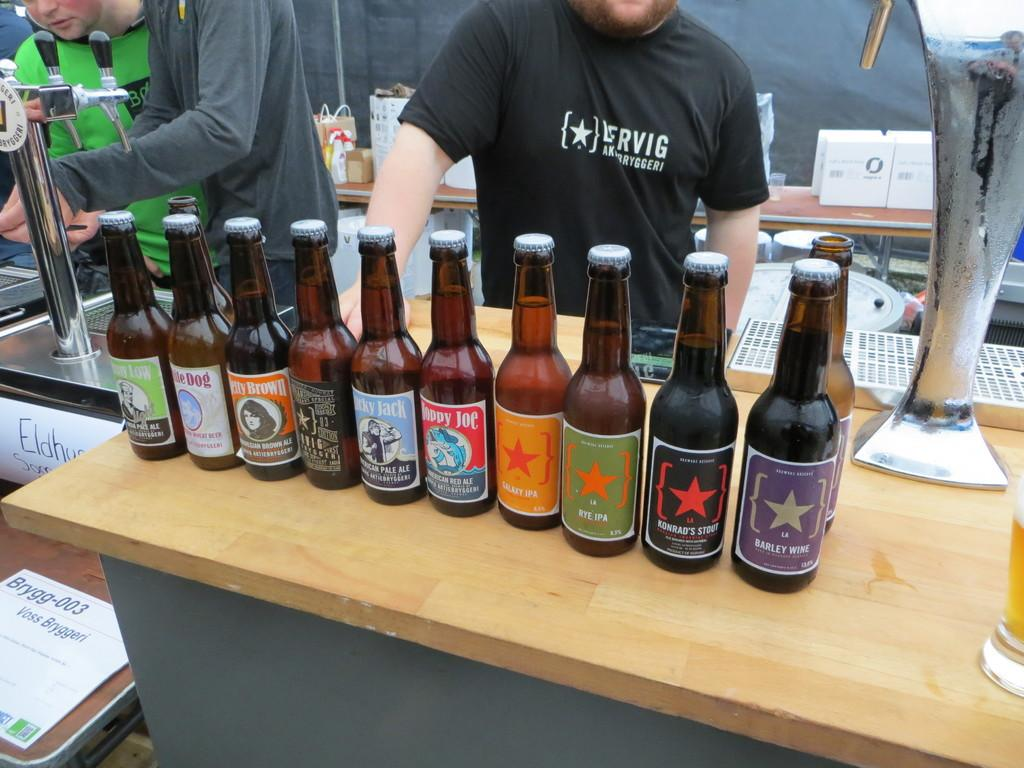What objects are on the table in the image? There are bottles on the table in the image. Can you describe the people in the background of the image? Unfortunately, the provided facts do not give any information about the people in the background. How many bottles are on the table? The provided facts do not specify the number of bottles on the table. What substance is being sorted by the people in the image? There are no people sorting any substance in the image; the provided facts only mention that there are people standing in the background. 